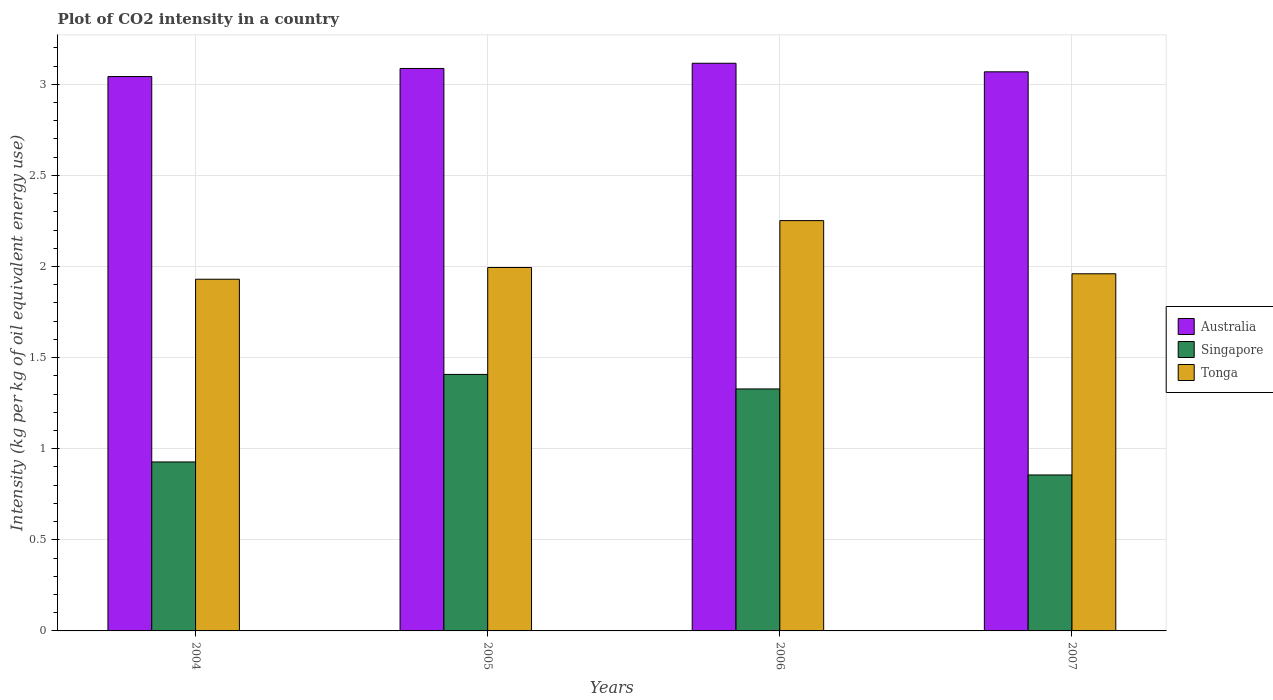How many bars are there on the 3rd tick from the left?
Your response must be concise. 3. In how many cases, is the number of bars for a given year not equal to the number of legend labels?
Keep it short and to the point. 0. What is the CO2 intensity in in Tonga in 2005?
Offer a very short reply. 1.99. Across all years, what is the maximum CO2 intensity in in Singapore?
Provide a succinct answer. 1.41. Across all years, what is the minimum CO2 intensity in in Australia?
Keep it short and to the point. 3.04. In which year was the CO2 intensity in in Australia maximum?
Provide a succinct answer. 2006. What is the total CO2 intensity in in Tonga in the graph?
Provide a succinct answer. 8.14. What is the difference between the CO2 intensity in in Singapore in 2004 and that in 2005?
Your response must be concise. -0.48. What is the difference between the CO2 intensity in in Singapore in 2006 and the CO2 intensity in in Australia in 2004?
Ensure brevity in your answer.  -1.71. What is the average CO2 intensity in in Australia per year?
Your response must be concise. 3.08. In the year 2004, what is the difference between the CO2 intensity in in Tonga and CO2 intensity in in Singapore?
Offer a terse response. 1. What is the ratio of the CO2 intensity in in Tonga in 2005 to that in 2006?
Provide a succinct answer. 0.89. Is the difference between the CO2 intensity in in Tonga in 2006 and 2007 greater than the difference between the CO2 intensity in in Singapore in 2006 and 2007?
Ensure brevity in your answer.  No. What is the difference between the highest and the second highest CO2 intensity in in Singapore?
Your answer should be compact. 0.08. What is the difference between the highest and the lowest CO2 intensity in in Australia?
Offer a terse response. 0.07. Is the sum of the CO2 intensity in in Tonga in 2004 and 2006 greater than the maximum CO2 intensity in in Singapore across all years?
Offer a terse response. Yes. What does the 3rd bar from the right in 2004 represents?
Offer a terse response. Australia. Is it the case that in every year, the sum of the CO2 intensity in in Australia and CO2 intensity in in Singapore is greater than the CO2 intensity in in Tonga?
Make the answer very short. Yes. How many years are there in the graph?
Provide a short and direct response. 4. What is the difference between two consecutive major ticks on the Y-axis?
Offer a terse response. 0.5. Does the graph contain any zero values?
Offer a very short reply. No. Where does the legend appear in the graph?
Make the answer very short. Center right. How are the legend labels stacked?
Provide a succinct answer. Vertical. What is the title of the graph?
Your response must be concise. Plot of CO2 intensity in a country. What is the label or title of the Y-axis?
Your answer should be very brief. Intensity (kg per kg of oil equivalent energy use). What is the Intensity (kg per kg of oil equivalent energy use) in Australia in 2004?
Provide a succinct answer. 3.04. What is the Intensity (kg per kg of oil equivalent energy use) in Singapore in 2004?
Offer a terse response. 0.93. What is the Intensity (kg per kg of oil equivalent energy use) in Tonga in 2004?
Provide a short and direct response. 1.93. What is the Intensity (kg per kg of oil equivalent energy use) in Australia in 2005?
Give a very brief answer. 3.09. What is the Intensity (kg per kg of oil equivalent energy use) in Singapore in 2005?
Your response must be concise. 1.41. What is the Intensity (kg per kg of oil equivalent energy use) of Tonga in 2005?
Offer a very short reply. 1.99. What is the Intensity (kg per kg of oil equivalent energy use) in Australia in 2006?
Your response must be concise. 3.12. What is the Intensity (kg per kg of oil equivalent energy use) in Singapore in 2006?
Keep it short and to the point. 1.33. What is the Intensity (kg per kg of oil equivalent energy use) of Tonga in 2006?
Make the answer very short. 2.25. What is the Intensity (kg per kg of oil equivalent energy use) of Australia in 2007?
Make the answer very short. 3.07. What is the Intensity (kg per kg of oil equivalent energy use) of Singapore in 2007?
Provide a succinct answer. 0.86. What is the Intensity (kg per kg of oil equivalent energy use) in Tonga in 2007?
Keep it short and to the point. 1.96. Across all years, what is the maximum Intensity (kg per kg of oil equivalent energy use) in Australia?
Offer a terse response. 3.12. Across all years, what is the maximum Intensity (kg per kg of oil equivalent energy use) of Singapore?
Provide a short and direct response. 1.41. Across all years, what is the maximum Intensity (kg per kg of oil equivalent energy use) of Tonga?
Provide a succinct answer. 2.25. Across all years, what is the minimum Intensity (kg per kg of oil equivalent energy use) of Australia?
Your response must be concise. 3.04. Across all years, what is the minimum Intensity (kg per kg of oil equivalent energy use) of Singapore?
Provide a succinct answer. 0.86. Across all years, what is the minimum Intensity (kg per kg of oil equivalent energy use) in Tonga?
Offer a terse response. 1.93. What is the total Intensity (kg per kg of oil equivalent energy use) in Australia in the graph?
Make the answer very short. 12.31. What is the total Intensity (kg per kg of oil equivalent energy use) of Singapore in the graph?
Your answer should be compact. 4.52. What is the total Intensity (kg per kg of oil equivalent energy use) of Tonga in the graph?
Your answer should be very brief. 8.14. What is the difference between the Intensity (kg per kg of oil equivalent energy use) of Australia in 2004 and that in 2005?
Offer a very short reply. -0.04. What is the difference between the Intensity (kg per kg of oil equivalent energy use) in Singapore in 2004 and that in 2005?
Provide a succinct answer. -0.48. What is the difference between the Intensity (kg per kg of oil equivalent energy use) in Tonga in 2004 and that in 2005?
Offer a very short reply. -0.06. What is the difference between the Intensity (kg per kg of oil equivalent energy use) of Australia in 2004 and that in 2006?
Make the answer very short. -0.07. What is the difference between the Intensity (kg per kg of oil equivalent energy use) in Singapore in 2004 and that in 2006?
Provide a short and direct response. -0.4. What is the difference between the Intensity (kg per kg of oil equivalent energy use) in Tonga in 2004 and that in 2006?
Provide a short and direct response. -0.32. What is the difference between the Intensity (kg per kg of oil equivalent energy use) in Australia in 2004 and that in 2007?
Ensure brevity in your answer.  -0.03. What is the difference between the Intensity (kg per kg of oil equivalent energy use) in Singapore in 2004 and that in 2007?
Provide a succinct answer. 0.07. What is the difference between the Intensity (kg per kg of oil equivalent energy use) of Tonga in 2004 and that in 2007?
Your response must be concise. -0.03. What is the difference between the Intensity (kg per kg of oil equivalent energy use) of Australia in 2005 and that in 2006?
Your answer should be compact. -0.03. What is the difference between the Intensity (kg per kg of oil equivalent energy use) of Singapore in 2005 and that in 2006?
Offer a terse response. 0.08. What is the difference between the Intensity (kg per kg of oil equivalent energy use) of Tonga in 2005 and that in 2006?
Offer a terse response. -0.26. What is the difference between the Intensity (kg per kg of oil equivalent energy use) of Australia in 2005 and that in 2007?
Provide a short and direct response. 0.02. What is the difference between the Intensity (kg per kg of oil equivalent energy use) of Singapore in 2005 and that in 2007?
Keep it short and to the point. 0.55. What is the difference between the Intensity (kg per kg of oil equivalent energy use) of Tonga in 2005 and that in 2007?
Provide a succinct answer. 0.03. What is the difference between the Intensity (kg per kg of oil equivalent energy use) in Australia in 2006 and that in 2007?
Your answer should be very brief. 0.05. What is the difference between the Intensity (kg per kg of oil equivalent energy use) in Singapore in 2006 and that in 2007?
Offer a terse response. 0.47. What is the difference between the Intensity (kg per kg of oil equivalent energy use) in Tonga in 2006 and that in 2007?
Give a very brief answer. 0.29. What is the difference between the Intensity (kg per kg of oil equivalent energy use) of Australia in 2004 and the Intensity (kg per kg of oil equivalent energy use) of Singapore in 2005?
Provide a succinct answer. 1.63. What is the difference between the Intensity (kg per kg of oil equivalent energy use) of Australia in 2004 and the Intensity (kg per kg of oil equivalent energy use) of Tonga in 2005?
Your response must be concise. 1.05. What is the difference between the Intensity (kg per kg of oil equivalent energy use) in Singapore in 2004 and the Intensity (kg per kg of oil equivalent energy use) in Tonga in 2005?
Your response must be concise. -1.07. What is the difference between the Intensity (kg per kg of oil equivalent energy use) of Australia in 2004 and the Intensity (kg per kg of oil equivalent energy use) of Singapore in 2006?
Ensure brevity in your answer.  1.71. What is the difference between the Intensity (kg per kg of oil equivalent energy use) in Australia in 2004 and the Intensity (kg per kg of oil equivalent energy use) in Tonga in 2006?
Ensure brevity in your answer.  0.79. What is the difference between the Intensity (kg per kg of oil equivalent energy use) in Singapore in 2004 and the Intensity (kg per kg of oil equivalent energy use) in Tonga in 2006?
Your answer should be very brief. -1.32. What is the difference between the Intensity (kg per kg of oil equivalent energy use) in Australia in 2004 and the Intensity (kg per kg of oil equivalent energy use) in Singapore in 2007?
Give a very brief answer. 2.19. What is the difference between the Intensity (kg per kg of oil equivalent energy use) in Australia in 2004 and the Intensity (kg per kg of oil equivalent energy use) in Tonga in 2007?
Make the answer very short. 1.08. What is the difference between the Intensity (kg per kg of oil equivalent energy use) in Singapore in 2004 and the Intensity (kg per kg of oil equivalent energy use) in Tonga in 2007?
Your answer should be very brief. -1.03. What is the difference between the Intensity (kg per kg of oil equivalent energy use) in Australia in 2005 and the Intensity (kg per kg of oil equivalent energy use) in Singapore in 2006?
Your response must be concise. 1.76. What is the difference between the Intensity (kg per kg of oil equivalent energy use) of Australia in 2005 and the Intensity (kg per kg of oil equivalent energy use) of Tonga in 2006?
Your response must be concise. 0.83. What is the difference between the Intensity (kg per kg of oil equivalent energy use) of Singapore in 2005 and the Intensity (kg per kg of oil equivalent energy use) of Tonga in 2006?
Provide a short and direct response. -0.84. What is the difference between the Intensity (kg per kg of oil equivalent energy use) in Australia in 2005 and the Intensity (kg per kg of oil equivalent energy use) in Singapore in 2007?
Keep it short and to the point. 2.23. What is the difference between the Intensity (kg per kg of oil equivalent energy use) of Australia in 2005 and the Intensity (kg per kg of oil equivalent energy use) of Tonga in 2007?
Offer a terse response. 1.13. What is the difference between the Intensity (kg per kg of oil equivalent energy use) of Singapore in 2005 and the Intensity (kg per kg of oil equivalent energy use) of Tonga in 2007?
Your answer should be very brief. -0.55. What is the difference between the Intensity (kg per kg of oil equivalent energy use) in Australia in 2006 and the Intensity (kg per kg of oil equivalent energy use) in Singapore in 2007?
Your response must be concise. 2.26. What is the difference between the Intensity (kg per kg of oil equivalent energy use) in Australia in 2006 and the Intensity (kg per kg of oil equivalent energy use) in Tonga in 2007?
Your response must be concise. 1.16. What is the difference between the Intensity (kg per kg of oil equivalent energy use) of Singapore in 2006 and the Intensity (kg per kg of oil equivalent energy use) of Tonga in 2007?
Your response must be concise. -0.63. What is the average Intensity (kg per kg of oil equivalent energy use) of Australia per year?
Ensure brevity in your answer.  3.08. What is the average Intensity (kg per kg of oil equivalent energy use) in Singapore per year?
Provide a short and direct response. 1.13. What is the average Intensity (kg per kg of oil equivalent energy use) in Tonga per year?
Your answer should be compact. 2.03. In the year 2004, what is the difference between the Intensity (kg per kg of oil equivalent energy use) in Australia and Intensity (kg per kg of oil equivalent energy use) in Singapore?
Your answer should be compact. 2.12. In the year 2004, what is the difference between the Intensity (kg per kg of oil equivalent energy use) in Australia and Intensity (kg per kg of oil equivalent energy use) in Tonga?
Make the answer very short. 1.11. In the year 2004, what is the difference between the Intensity (kg per kg of oil equivalent energy use) in Singapore and Intensity (kg per kg of oil equivalent energy use) in Tonga?
Your response must be concise. -1. In the year 2005, what is the difference between the Intensity (kg per kg of oil equivalent energy use) of Australia and Intensity (kg per kg of oil equivalent energy use) of Singapore?
Your answer should be compact. 1.68. In the year 2005, what is the difference between the Intensity (kg per kg of oil equivalent energy use) of Australia and Intensity (kg per kg of oil equivalent energy use) of Tonga?
Give a very brief answer. 1.09. In the year 2005, what is the difference between the Intensity (kg per kg of oil equivalent energy use) in Singapore and Intensity (kg per kg of oil equivalent energy use) in Tonga?
Your response must be concise. -0.59. In the year 2006, what is the difference between the Intensity (kg per kg of oil equivalent energy use) of Australia and Intensity (kg per kg of oil equivalent energy use) of Singapore?
Your answer should be compact. 1.79. In the year 2006, what is the difference between the Intensity (kg per kg of oil equivalent energy use) of Australia and Intensity (kg per kg of oil equivalent energy use) of Tonga?
Offer a very short reply. 0.86. In the year 2006, what is the difference between the Intensity (kg per kg of oil equivalent energy use) in Singapore and Intensity (kg per kg of oil equivalent energy use) in Tonga?
Your response must be concise. -0.92. In the year 2007, what is the difference between the Intensity (kg per kg of oil equivalent energy use) in Australia and Intensity (kg per kg of oil equivalent energy use) in Singapore?
Provide a short and direct response. 2.21. In the year 2007, what is the difference between the Intensity (kg per kg of oil equivalent energy use) of Australia and Intensity (kg per kg of oil equivalent energy use) of Tonga?
Give a very brief answer. 1.11. In the year 2007, what is the difference between the Intensity (kg per kg of oil equivalent energy use) in Singapore and Intensity (kg per kg of oil equivalent energy use) in Tonga?
Give a very brief answer. -1.1. What is the ratio of the Intensity (kg per kg of oil equivalent energy use) in Australia in 2004 to that in 2005?
Offer a very short reply. 0.99. What is the ratio of the Intensity (kg per kg of oil equivalent energy use) in Singapore in 2004 to that in 2005?
Offer a terse response. 0.66. What is the ratio of the Intensity (kg per kg of oil equivalent energy use) of Australia in 2004 to that in 2006?
Your response must be concise. 0.98. What is the ratio of the Intensity (kg per kg of oil equivalent energy use) of Singapore in 2004 to that in 2006?
Your response must be concise. 0.7. What is the ratio of the Intensity (kg per kg of oil equivalent energy use) of Tonga in 2004 to that in 2006?
Offer a very short reply. 0.86. What is the ratio of the Intensity (kg per kg of oil equivalent energy use) in Tonga in 2004 to that in 2007?
Offer a terse response. 0.98. What is the ratio of the Intensity (kg per kg of oil equivalent energy use) in Singapore in 2005 to that in 2006?
Provide a short and direct response. 1.06. What is the ratio of the Intensity (kg per kg of oil equivalent energy use) of Tonga in 2005 to that in 2006?
Offer a terse response. 0.89. What is the ratio of the Intensity (kg per kg of oil equivalent energy use) in Australia in 2005 to that in 2007?
Your response must be concise. 1.01. What is the ratio of the Intensity (kg per kg of oil equivalent energy use) in Singapore in 2005 to that in 2007?
Provide a succinct answer. 1.64. What is the ratio of the Intensity (kg per kg of oil equivalent energy use) of Tonga in 2005 to that in 2007?
Offer a very short reply. 1.02. What is the ratio of the Intensity (kg per kg of oil equivalent energy use) in Australia in 2006 to that in 2007?
Offer a very short reply. 1.02. What is the ratio of the Intensity (kg per kg of oil equivalent energy use) of Singapore in 2006 to that in 2007?
Ensure brevity in your answer.  1.55. What is the ratio of the Intensity (kg per kg of oil equivalent energy use) of Tonga in 2006 to that in 2007?
Your answer should be compact. 1.15. What is the difference between the highest and the second highest Intensity (kg per kg of oil equivalent energy use) of Australia?
Give a very brief answer. 0.03. What is the difference between the highest and the second highest Intensity (kg per kg of oil equivalent energy use) of Singapore?
Give a very brief answer. 0.08. What is the difference between the highest and the second highest Intensity (kg per kg of oil equivalent energy use) in Tonga?
Give a very brief answer. 0.26. What is the difference between the highest and the lowest Intensity (kg per kg of oil equivalent energy use) of Australia?
Your answer should be compact. 0.07. What is the difference between the highest and the lowest Intensity (kg per kg of oil equivalent energy use) in Singapore?
Provide a short and direct response. 0.55. What is the difference between the highest and the lowest Intensity (kg per kg of oil equivalent energy use) of Tonga?
Your answer should be very brief. 0.32. 